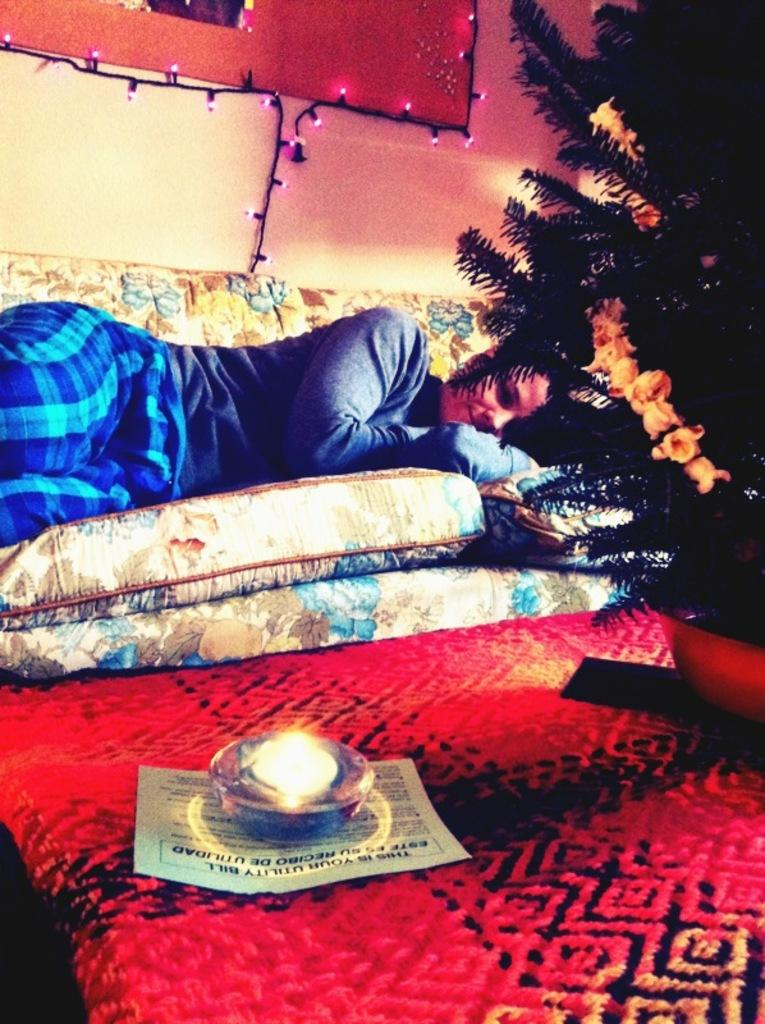What is the person in the image doing? The person is lying on the sofa. What holiday-related object can be seen in the image? There is a Christmas tree in the image. Where is the Christmas tree located in relation to the person? The Christmas tree is located to the right of the person. What can be seen on the wall in the background of the image? There are lights on the wall in the background. What type of wood is the sofa made of in the image? The facts provided do not mention the material of the sofa, so it cannot be determined from the image. 